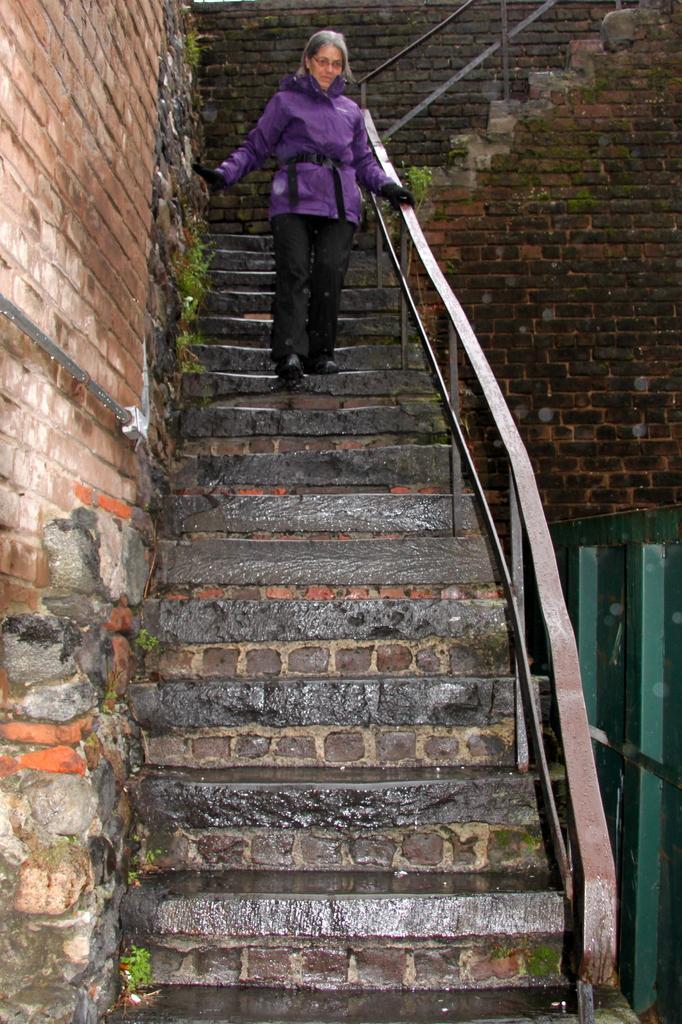Can you describe this image briefly? In this image there is the wall, staircase, on which there is a person, some wooden objects visible on the right side. 